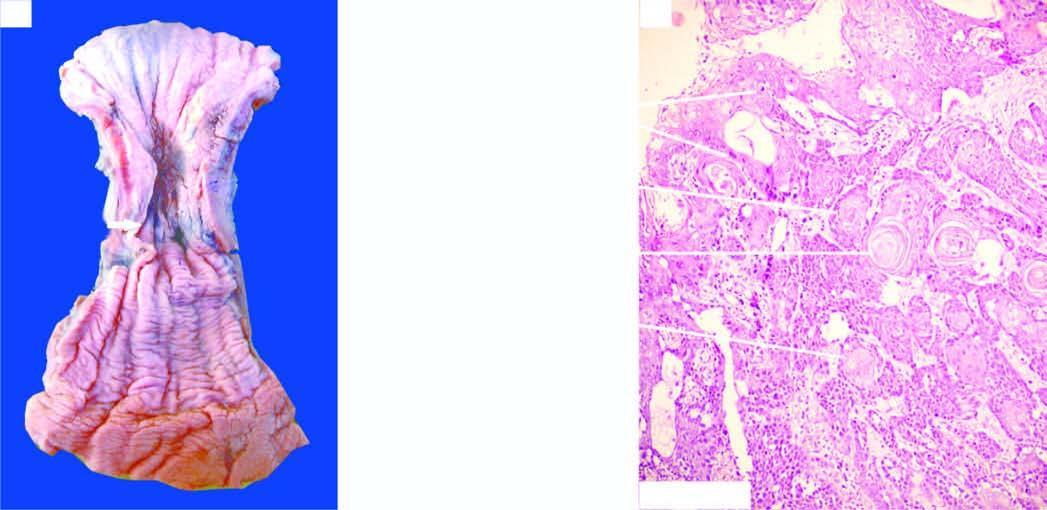does endothelial injury show whorls of anaplastic squamous cells invading the underlying soft tissues?
Answer the question using a single word or phrase. No 